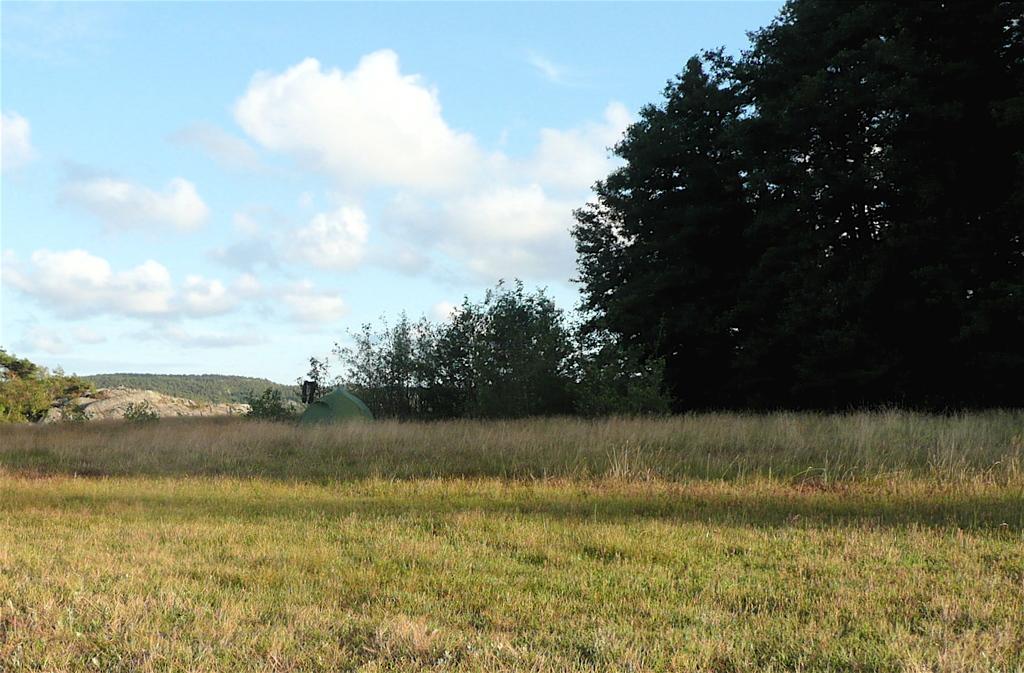Could you give a brief overview of what you see in this image? In this image I can see the grass. On the right side, I can see the trees. In the background, I can see the clouds in the sky. 